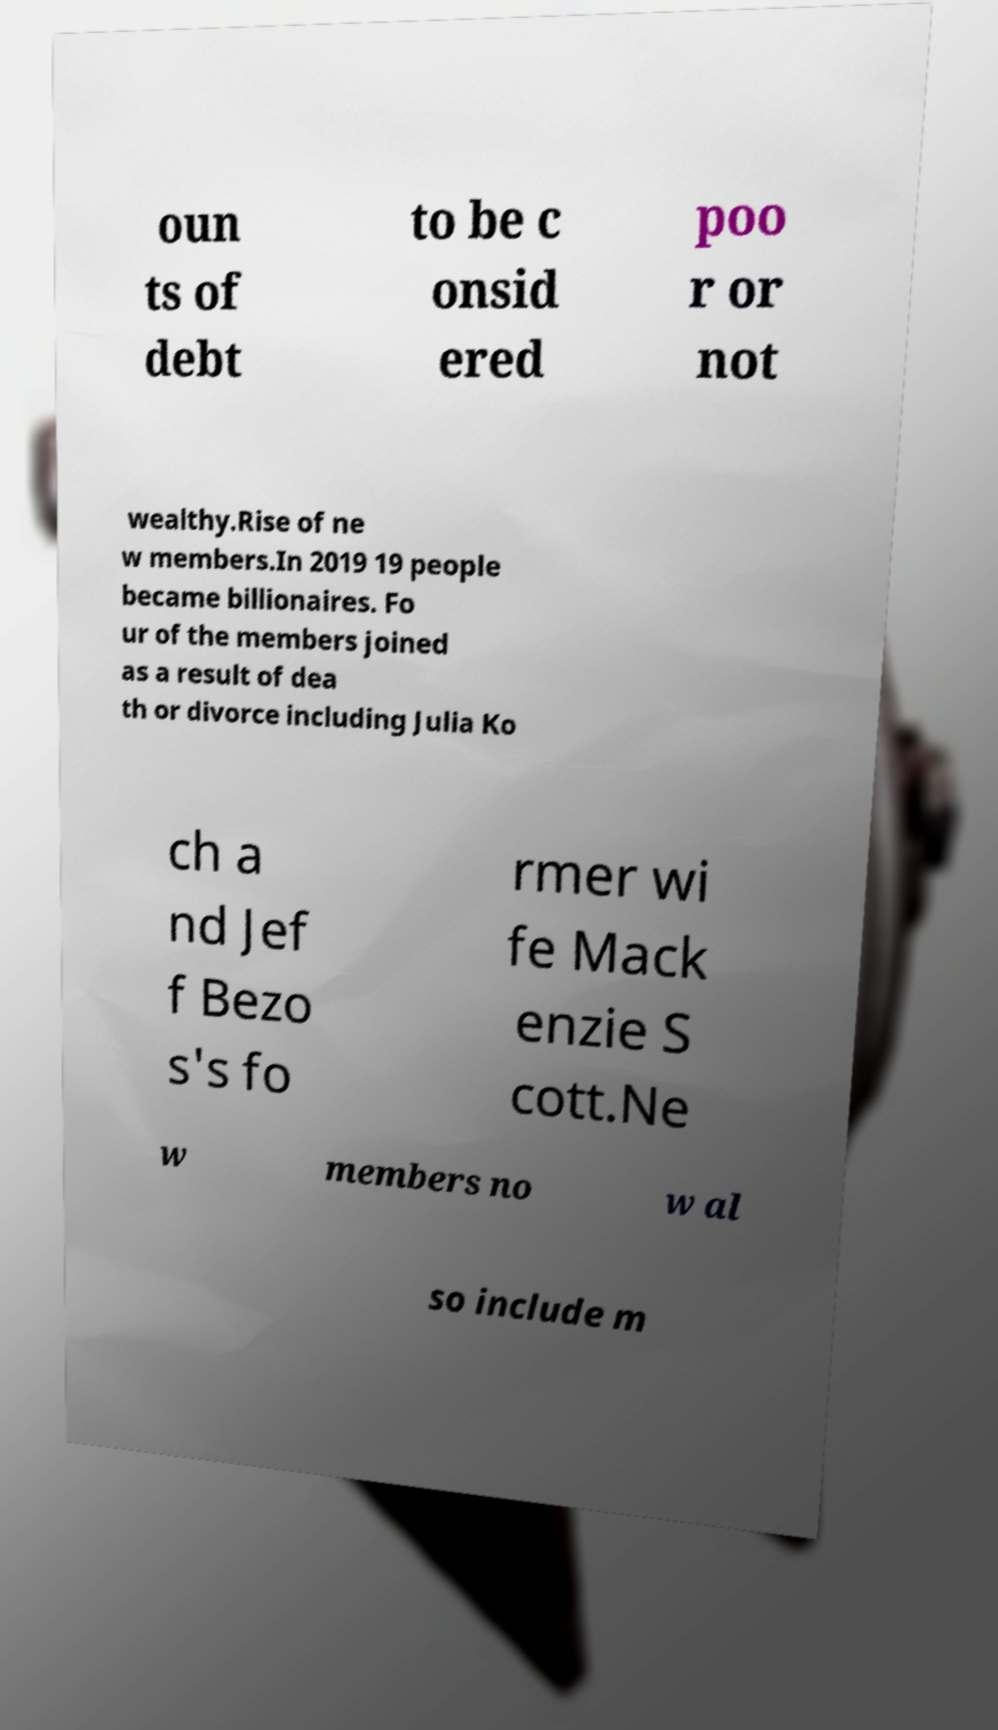Could you extract and type out the text from this image? oun ts of debt to be c onsid ered poo r or not wealthy.Rise of ne w members.In 2019 19 people became billionaires. Fo ur of the members joined as a result of dea th or divorce including Julia Ko ch a nd Jef f Bezo s's fo rmer wi fe Mack enzie S cott.Ne w members no w al so include m 